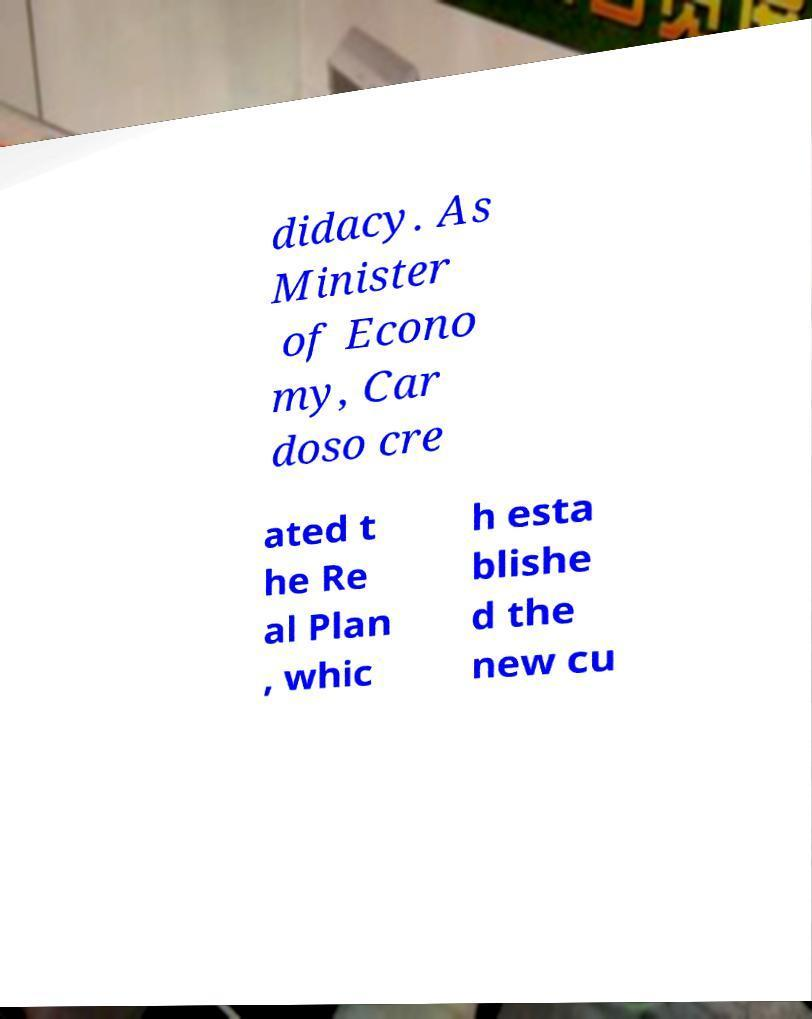There's text embedded in this image that I need extracted. Can you transcribe it verbatim? didacy. As Minister of Econo my, Car doso cre ated t he Re al Plan , whic h esta blishe d the new cu 